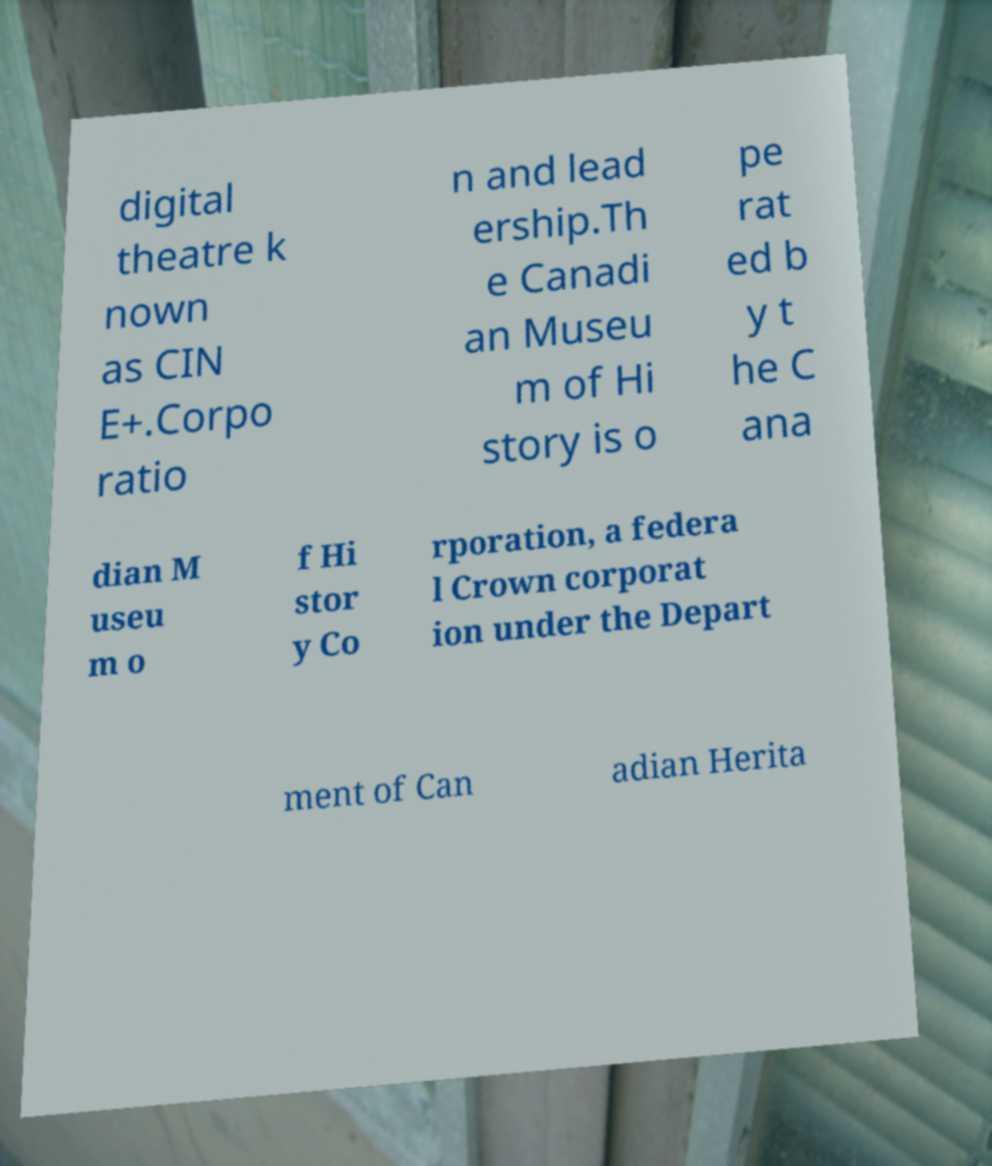Can you accurately transcribe the text from the provided image for me? digital theatre k nown as CIN E+.Corpo ratio n and lead ership.Th e Canadi an Museu m of Hi story is o pe rat ed b y t he C ana dian M useu m o f Hi stor y Co rporation, a federa l Crown corporat ion under the Depart ment of Can adian Herita 